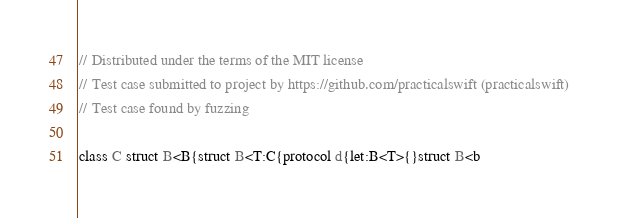<code> <loc_0><loc_0><loc_500><loc_500><_Swift_>// Distributed under the terms of the MIT license
// Test case submitted to project by https://github.com/practicalswift (practicalswift)
// Test case found by fuzzing

class C struct B<B{struct B<T:C{protocol d{let:B<T>{}struct B<b
</code> 